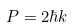Convert formula to latex. <formula><loc_0><loc_0><loc_500><loc_500>P = 2 \hbar { k }</formula> 